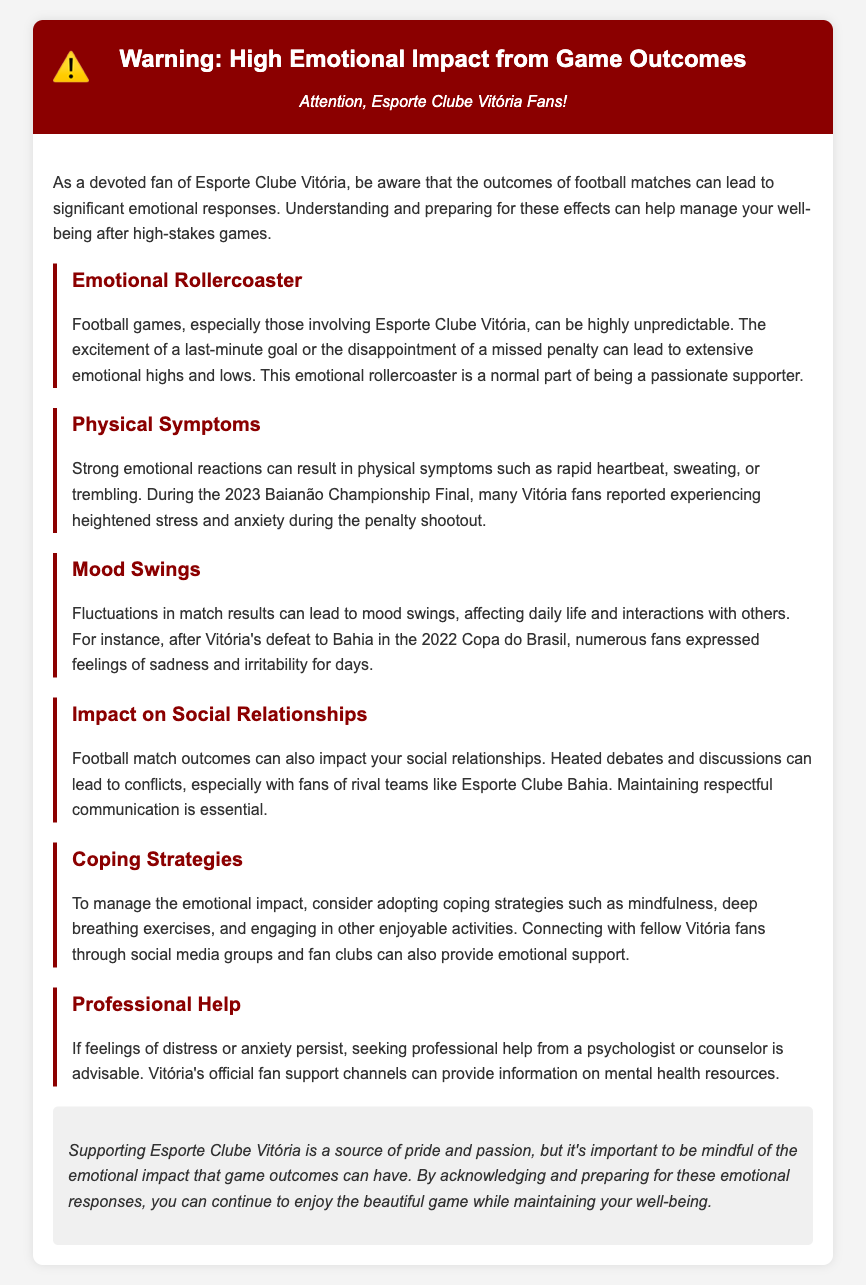what is the title of the document? The title is found in the header section of the document.
Answer: Warning: High Emotional Impact from Game Outcomes who is the target audience of this document? The subtitle explicitly addresses the audience in the document.
Answer: Esporte Clube Vitória Fans what emotion can football match outcomes cause? The content discusses the emotional responses to match outcomes.
Answer: Significant emotional responses which physical symptoms are mentioned? The document lists symptoms caused by emotional reactions.
Answer: Rapid heartbeat, sweating, or trembling what coping strategies are suggested? The document outlines strategies in one of the sections.
Answer: Mindfulness, deep breathing exercises, and engaging in enjoyable activities how did Vitória fans feel after the defeat to Bahia? The document provides specific feelings expressed by fans post-defeat.
Answer: Sadness and irritability what is advised if feelings of distress persist? The document recommends a course of action for ongoing distress.
Answer: Seeking professional help which match is referenced in relation to heightened stress? The document cites a specific event tied to emotional reactions.
Answer: 2023 Baianão Championship Final how can social relationships be impacted according to the document? The document discusses the influence of football outcomes on personal interactions.
Answer: Heated debates and conflicts 